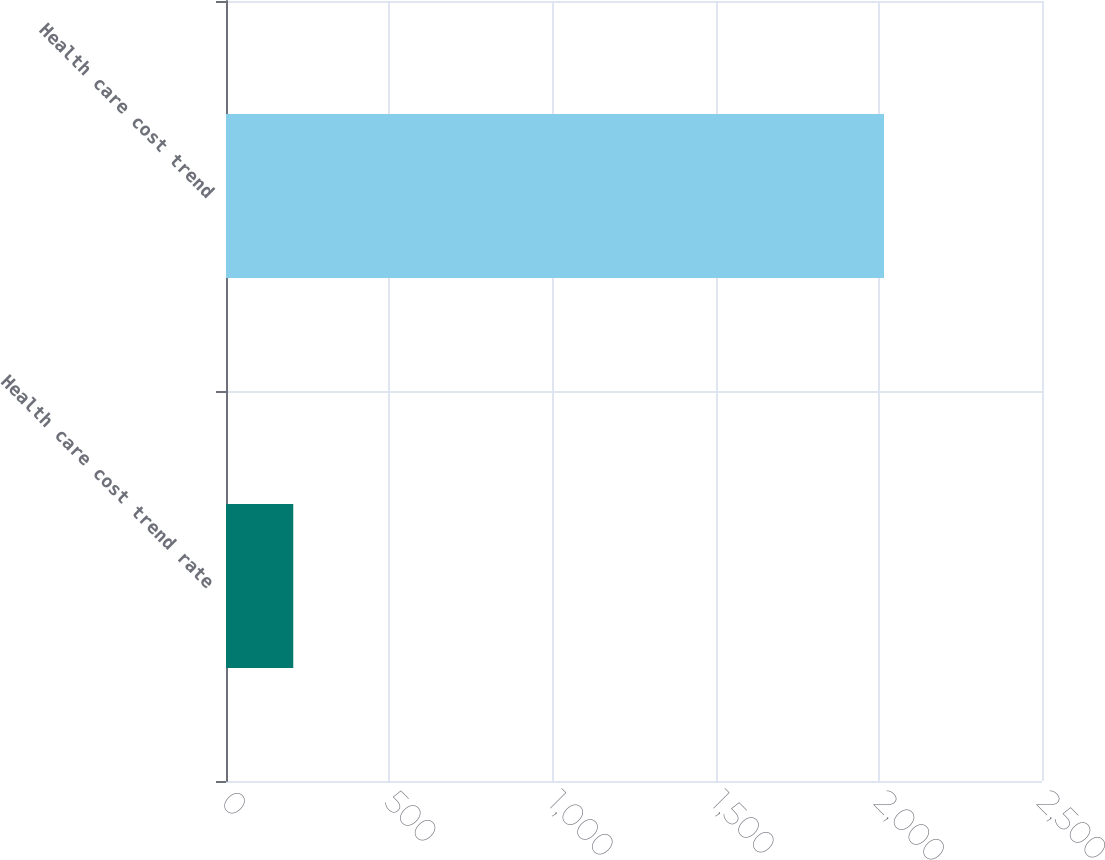Convert chart. <chart><loc_0><loc_0><loc_500><loc_500><bar_chart><fcel>Health care cost trend rate<fcel>Health care cost trend<nl><fcel>206.1<fcel>2016<nl></chart> 